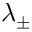Convert formula to latex. <formula><loc_0><loc_0><loc_500><loc_500>\lambda _ { \pm }</formula> 